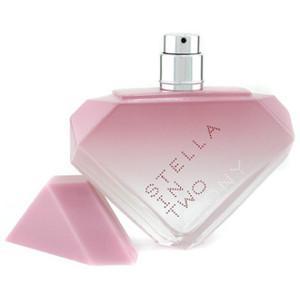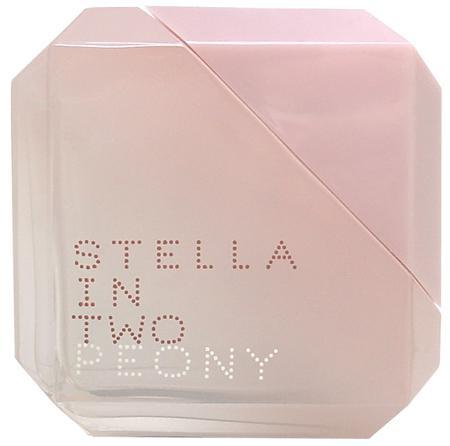The first image is the image on the left, the second image is the image on the right. Analyze the images presented: Is the assertion "A perfume bottle is standing on one corner with the lid off." valid? Answer yes or no. Yes. The first image is the image on the left, the second image is the image on the right. Considering the images on both sides, is "One image contains a bottle shaped like an inverted triangle with its triangular cap alongside it, and the other image includes a bevel-edged square pink object." valid? Answer yes or no. Yes. 